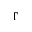<formula> <loc_0><loc_0><loc_500><loc_500>\Gamma</formula> 